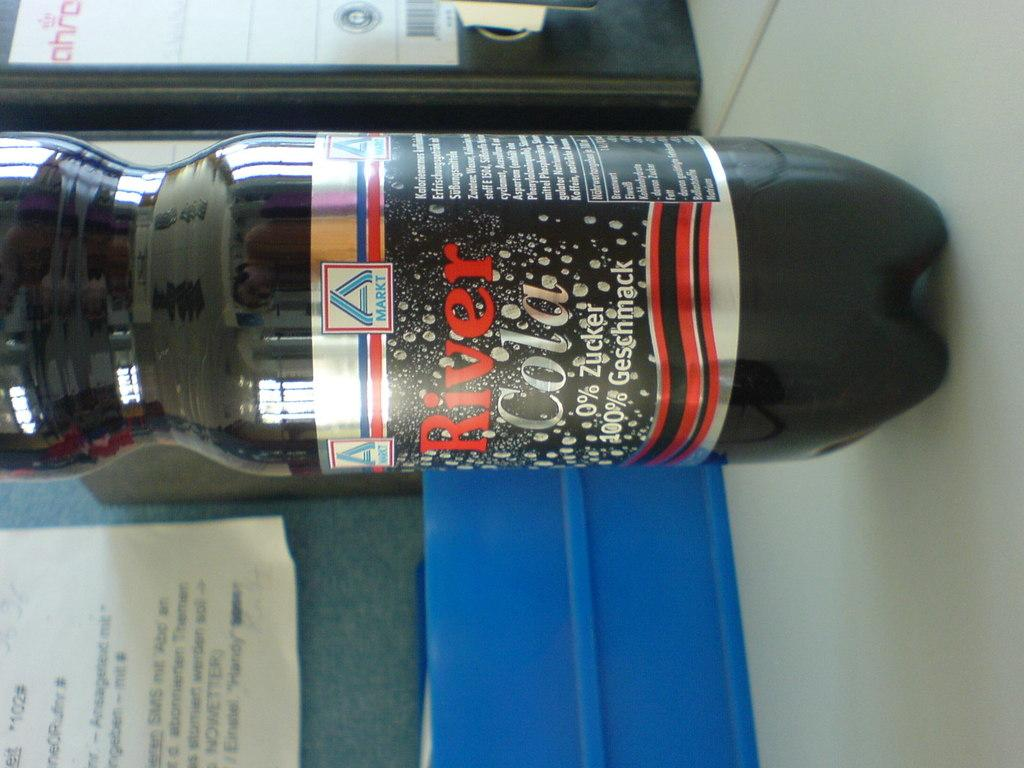<image>
Create a compact narrative representing the image presented. A bottle of river cola sitting on a desk. 